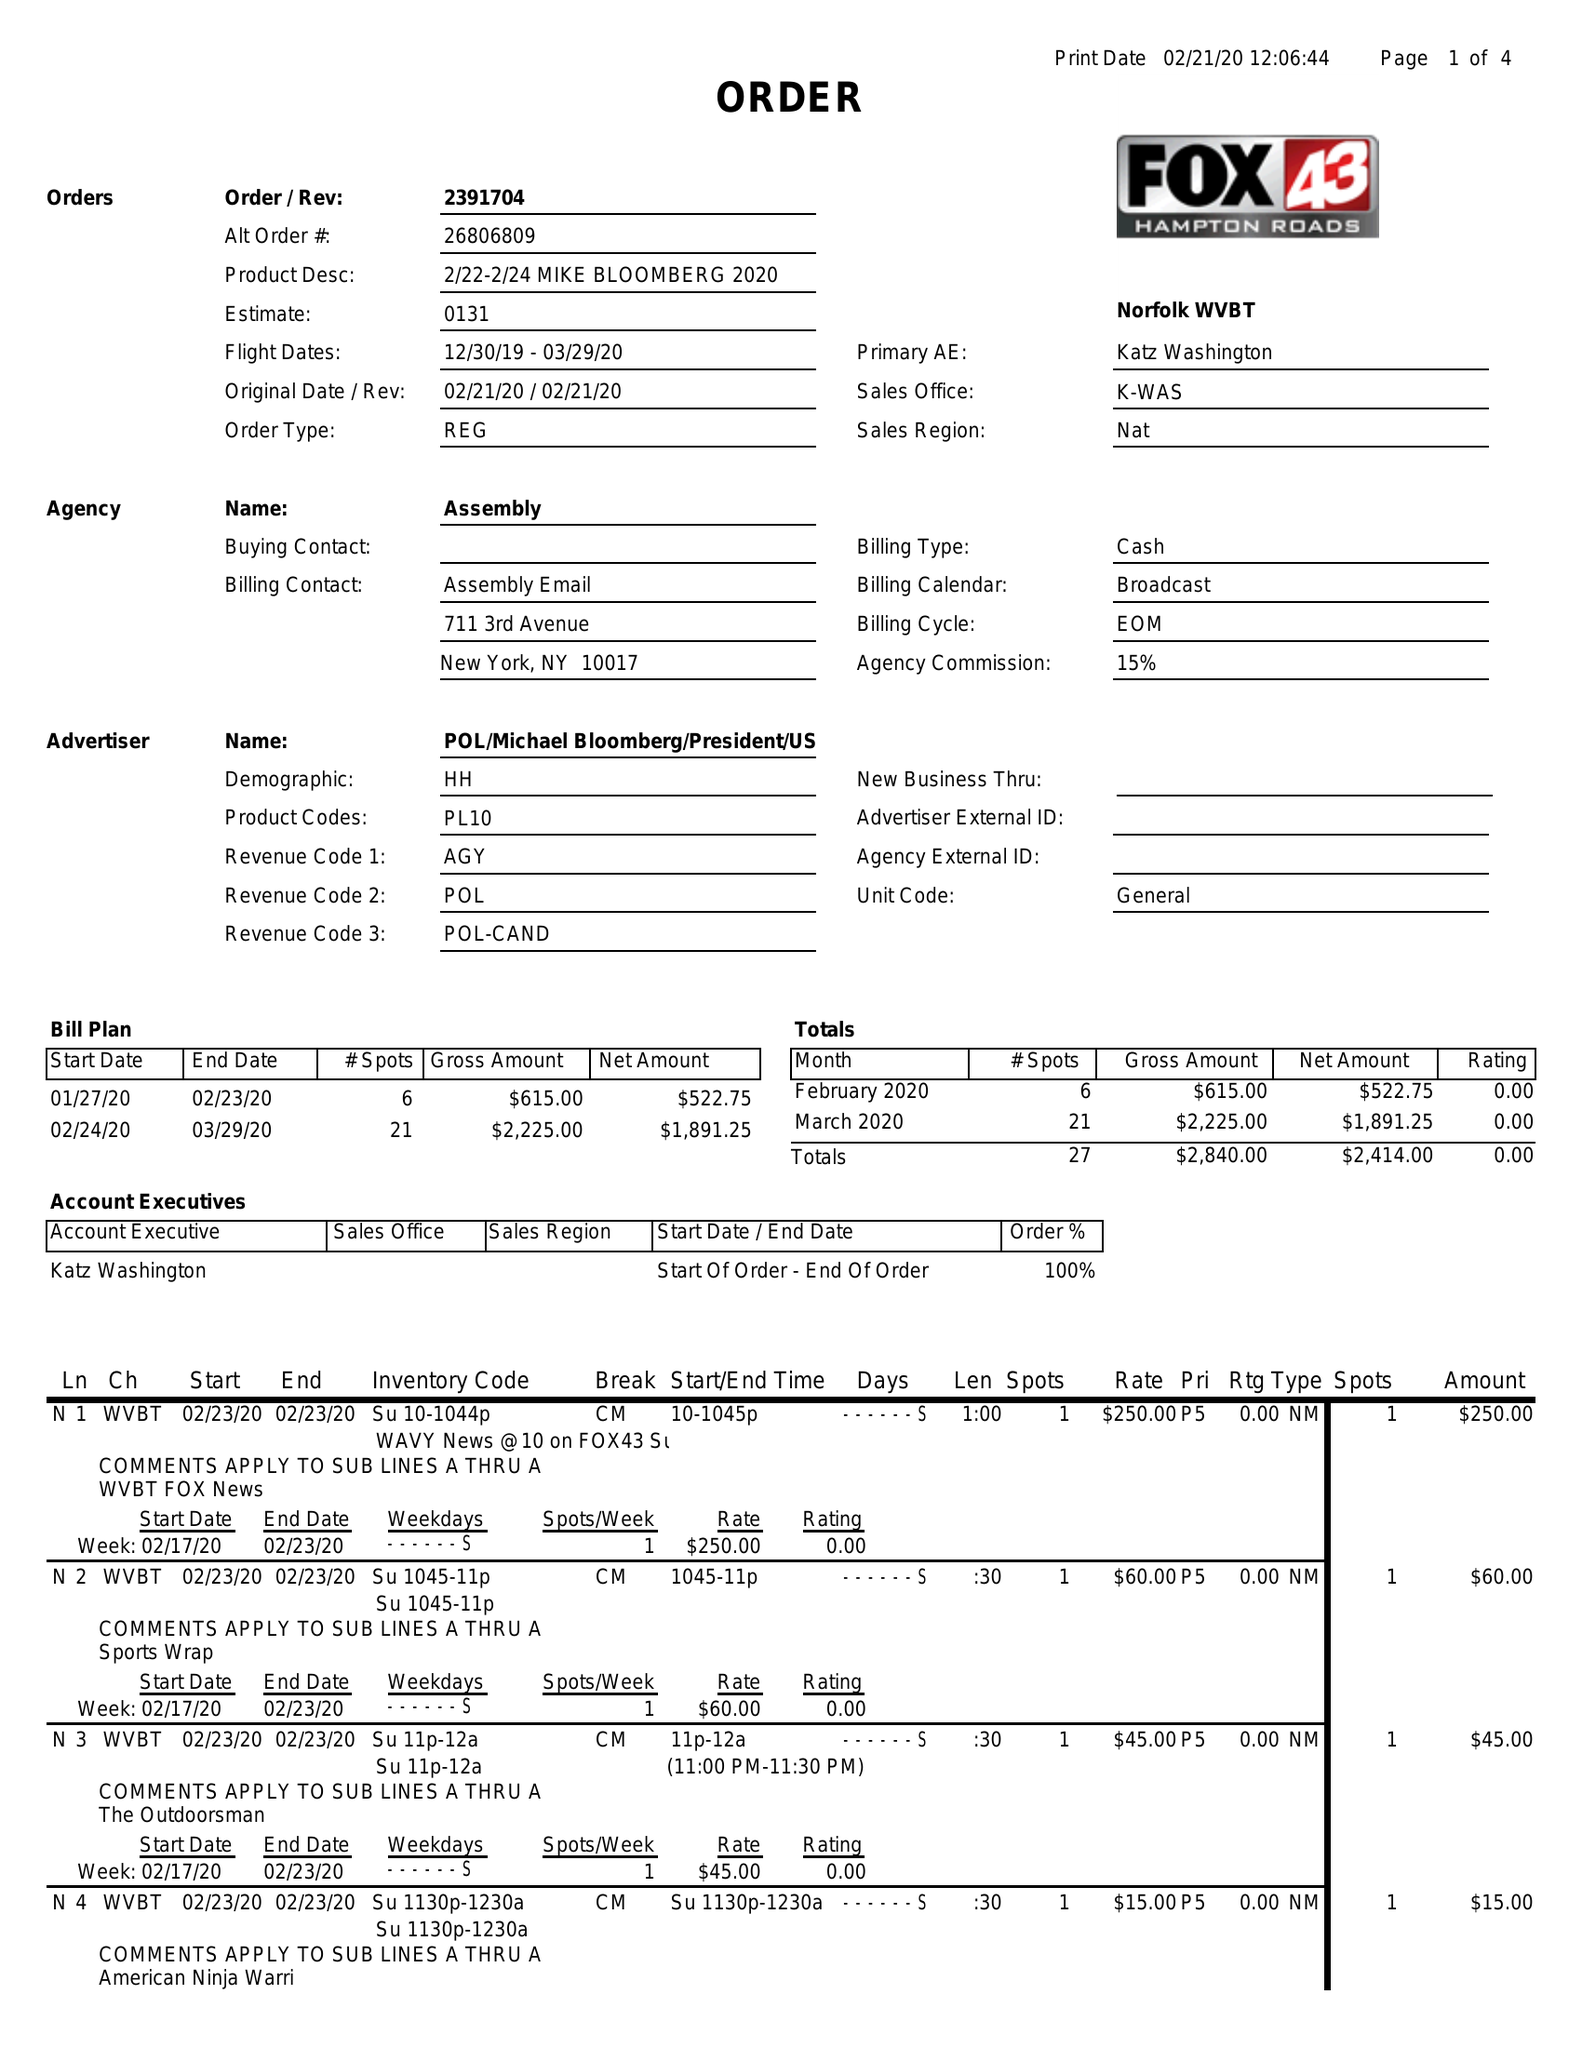What is the value for the advertiser?
Answer the question using a single word or phrase. POL/MICHAELBLOOMBERG/PRESIDENT/US/DEM 